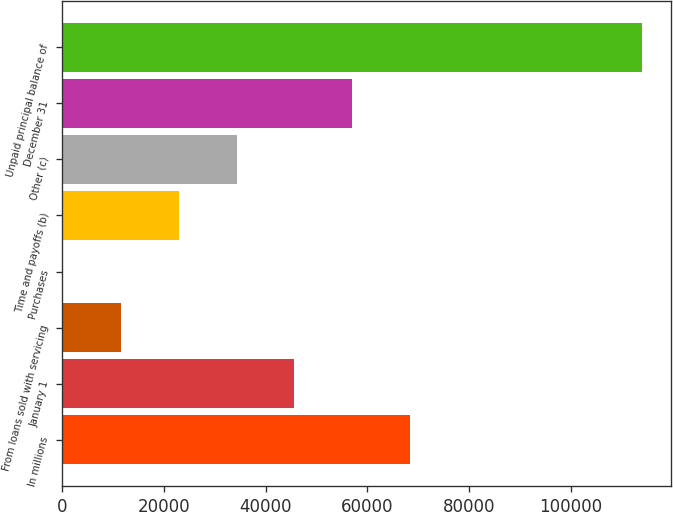Convert chart. <chart><loc_0><loc_0><loc_500><loc_500><bar_chart><fcel>In millions<fcel>January 1<fcel>From loans sold with servicing<fcel>Purchases<fcel>Time and payoffs (b)<fcel>Other (c)<fcel>December 31<fcel>Unpaid principal balance of<nl><fcel>68440.4<fcel>45663.6<fcel>11498.4<fcel>110<fcel>22886.8<fcel>34275.2<fcel>57052<fcel>113994<nl></chart> 